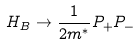<formula> <loc_0><loc_0><loc_500><loc_500>H _ { B } \rightarrow \frac { 1 } { 2 m ^ { * } } P _ { + } P _ { - }</formula> 